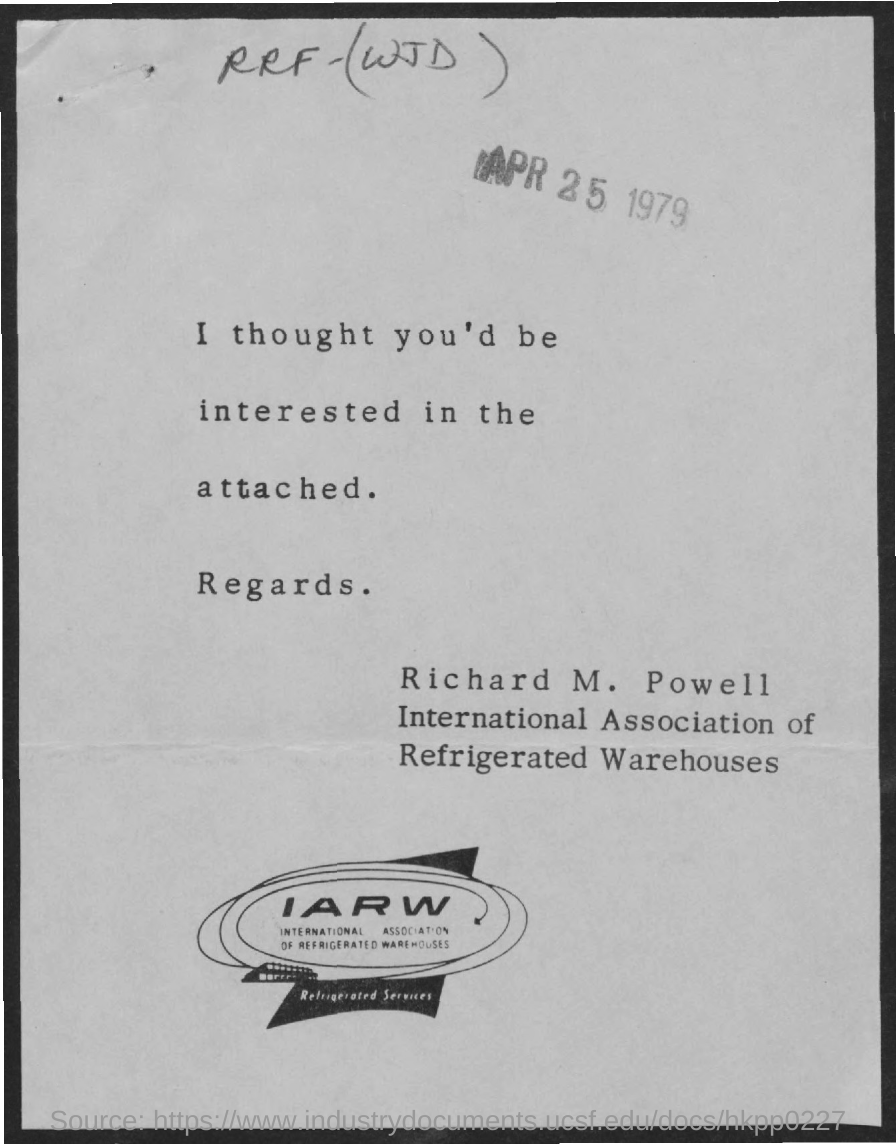What is the fullform of IARW?
Offer a very short reply. International Association of Refrigerated Warehouses. What is this document dated?
Your answer should be very brief. APR 25 1979. Which person is from IARW?
Provide a succinct answer. RICHARD M. POWELL. 